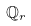<formula> <loc_0><loc_0><loc_500><loc_500>\mathbb { Q } _ { r }</formula> 